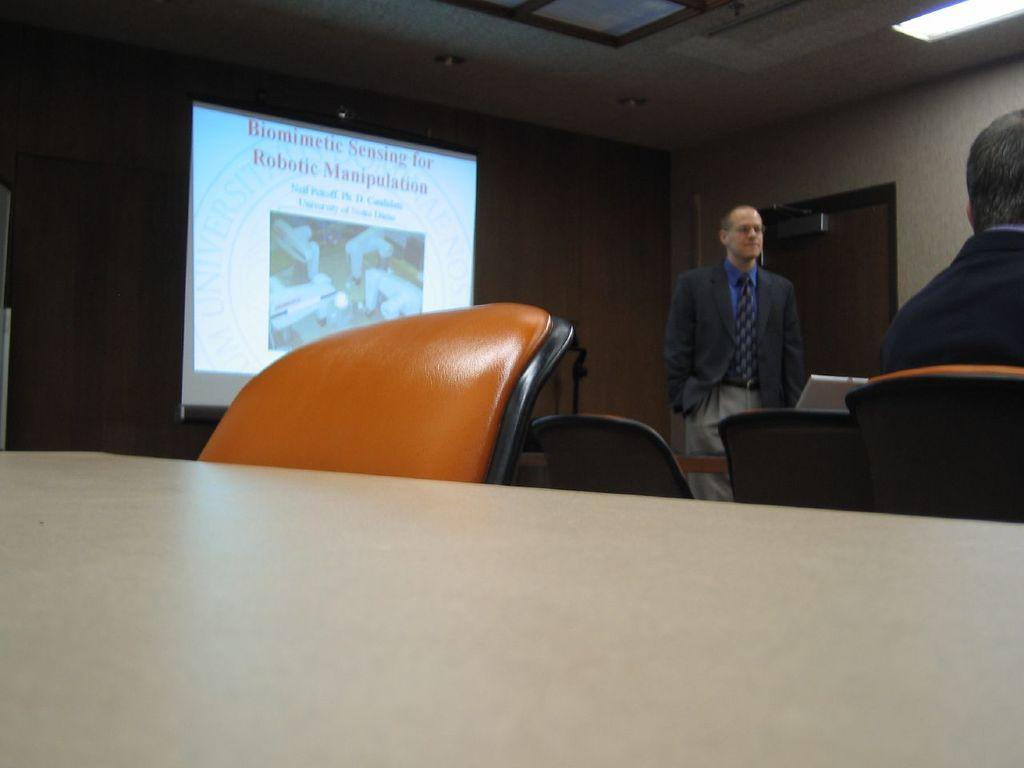What is the main subject of the image? There is a man standing in the image. What object is the man using or interacting with? There is a laptop in the image. What is visible on the laptop? There is a screen visible in the image. Are there any other objects in the image besides the man and laptop? Yes, there are chairs in the image. What type of lock is the man using to secure the guitar in the image? There is no lock or guitar present in the image. 